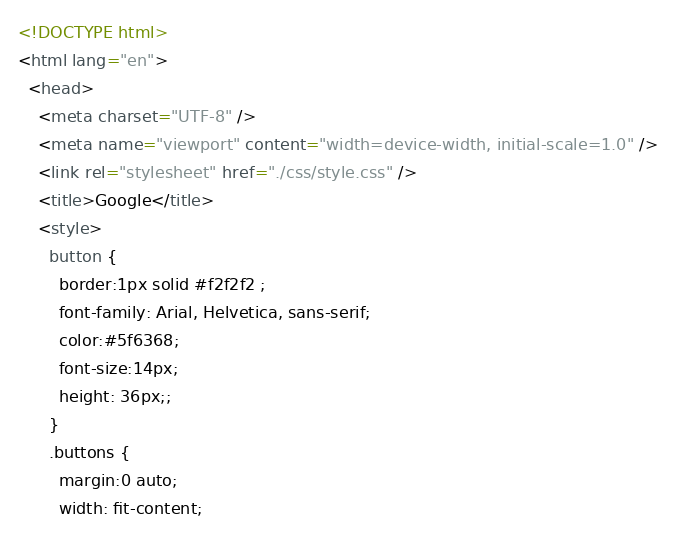Convert code to text. <code><loc_0><loc_0><loc_500><loc_500><_HTML_><!DOCTYPE html>
<html lang="en">
  <head>
    <meta charset="UTF-8" />
    <meta name="viewport" content="width=device-width, initial-scale=1.0" />
    <link rel="stylesheet" href="./css/style.css" />
    <title>Google</title>
    <style>
      button {
        border:1px solid #f2f2f2 ;
        font-family: Arial, Helvetica, sans-serif;
        color:#5f6368;
        font-size:14px;
        height: 36px;;
      }
      .buttons {
        margin:0 auto;
        width: fit-content;</code> 